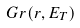<formula> <loc_0><loc_0><loc_500><loc_500>G r ( r , E _ { T } )</formula> 